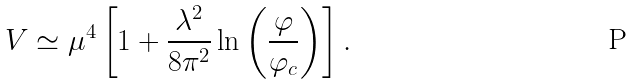<formula> <loc_0><loc_0><loc_500><loc_500>V \simeq \mu ^ { 4 } \left [ 1 + \frac { \lambda ^ { 2 } } { 8 \pi ^ { 2 } } \ln \left ( \frac { \varphi } { \varphi _ { c } } \right ) \right ] .</formula> 